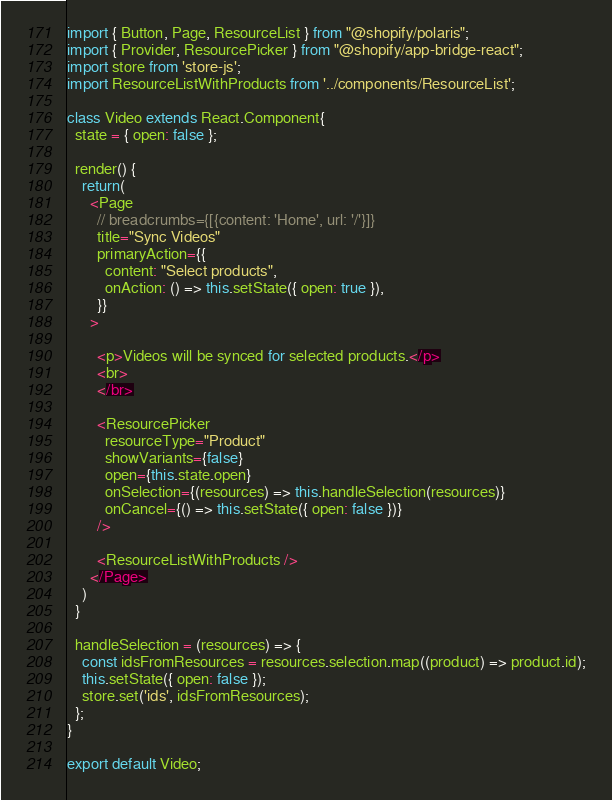<code> <loc_0><loc_0><loc_500><loc_500><_JavaScript_>import { Button, Page, ResourceList } from "@shopify/polaris";
import { Provider, ResourcePicker } from "@shopify/app-bridge-react";
import store from 'store-js';
import ResourceListWithProducts from '../components/ResourceList';

class Video extends React.Component{
  state = { open: false };

  render() {
    return(
      <Page
        // breadcrumbs={[{content: 'Home', url: '/'}]}
        title="Sync Videos"
        primaryAction={{
          content: "Select products",
          onAction: () => this.setState({ open: true }),
        }}
      >

        <p>Videos will be synced for selected products.</p>
        <br>
        </br>

        <ResourcePicker
          resourceType="Product"
          showVariants={false}
          open={this.state.open}
          onSelection={(resources) => this.handleSelection(resources)}
          onCancel={() => this.setState({ open: false })}
        />

        <ResourceListWithProducts />
      </Page>
    )
  }

  handleSelection = (resources) => {
    const idsFromResources = resources.selection.map((product) => product.id);
    this.setState({ open: false });
    store.set('ids', idsFromResources);
  };
}

export default Video;</code> 